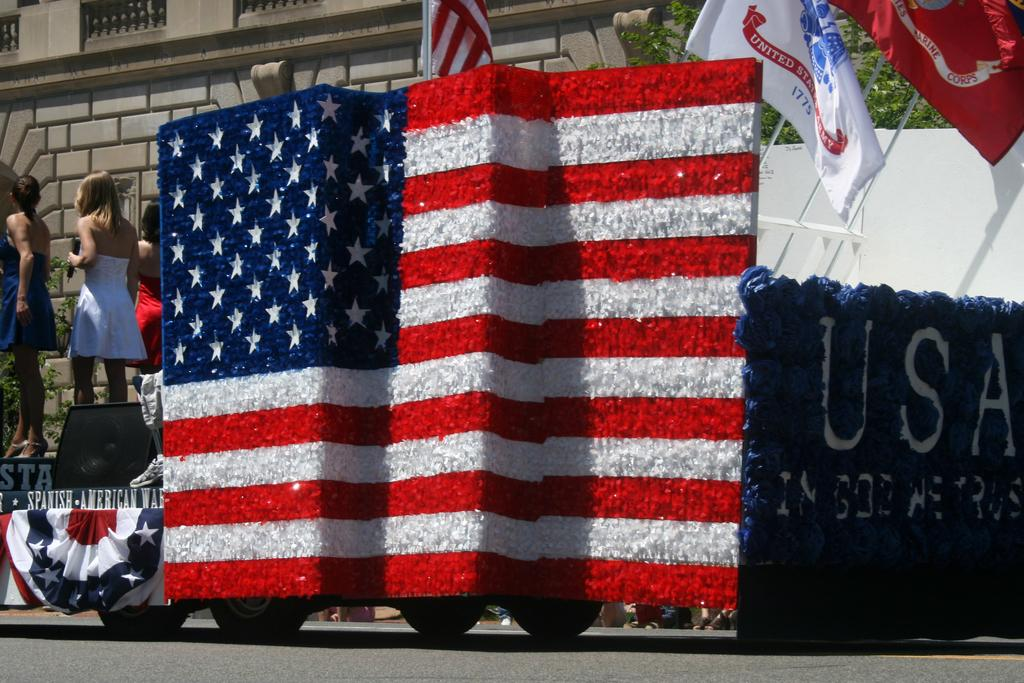<image>
Offer a succinct explanation of the picture presented. A parade float commemorating the Spanish American War. 